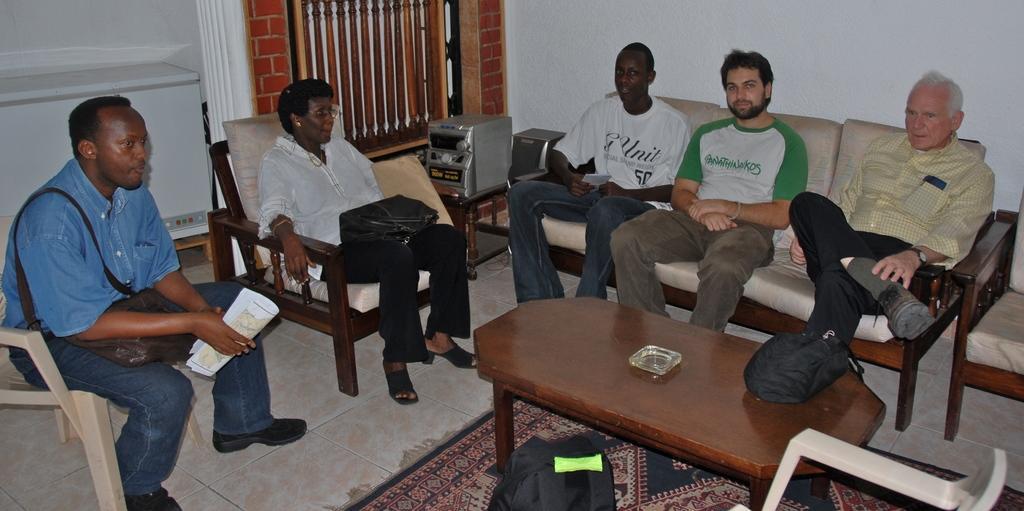How would you summarize this image in a sentence or two? This image consists of five persons. At the bottom, there is floor mat on the floor. In the middle, there is a table. In the front , we can see a window along with music player. On the right, there is a wall. 